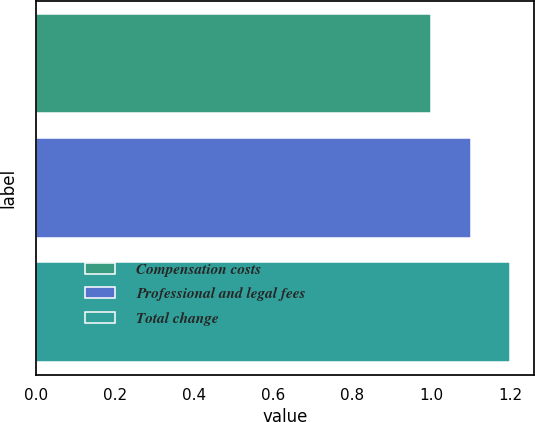Convert chart to OTSL. <chart><loc_0><loc_0><loc_500><loc_500><bar_chart><fcel>Compensation costs<fcel>Professional and legal fees<fcel>Total change<nl><fcel>1<fcel>1.1<fcel>1.2<nl></chart> 